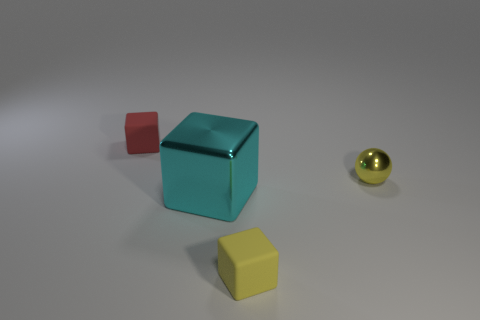The other big metal thing that is the same shape as the red thing is what color?
Make the answer very short. Cyan. The shiny thing that is the same shape as the small yellow matte thing is what size?
Your response must be concise. Large. What number of other things are the same material as the small sphere?
Provide a succinct answer. 1. Are the yellow ball that is right of the cyan block and the big block made of the same material?
Your answer should be very brief. Yes. There is a rubber object that is in front of the shiny thing right of the rubber object in front of the big cyan metal thing; what size is it?
Your response must be concise. Small. How many other objects are the same color as the small metallic sphere?
Your answer should be very brief. 1. What shape is the red object that is the same size as the yellow metal object?
Provide a short and direct response. Cube. There is a yellow rubber object that is in front of the big cyan object; how big is it?
Offer a terse response. Small. There is a object that is to the left of the cyan cube; is it the same color as the rubber thing right of the large block?
Make the answer very short. No. What is the tiny object that is to the left of the tiny block in front of the cube behind the small yellow sphere made of?
Ensure brevity in your answer.  Rubber. 